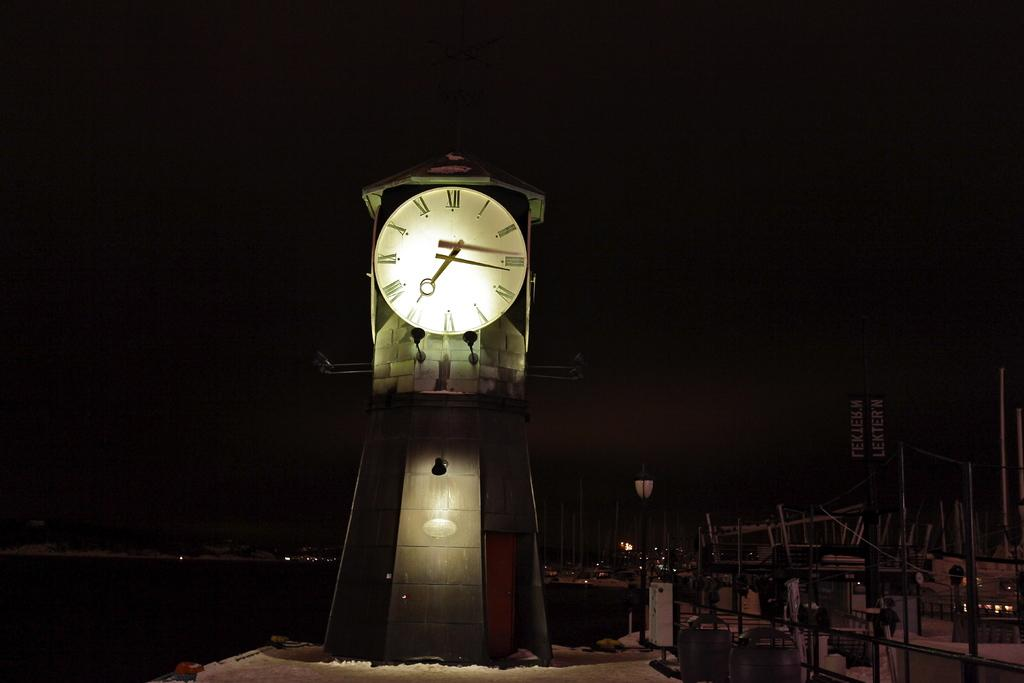<image>
Describe the image concisely. A clock outside of the marina points to the numbers 3 and 7 